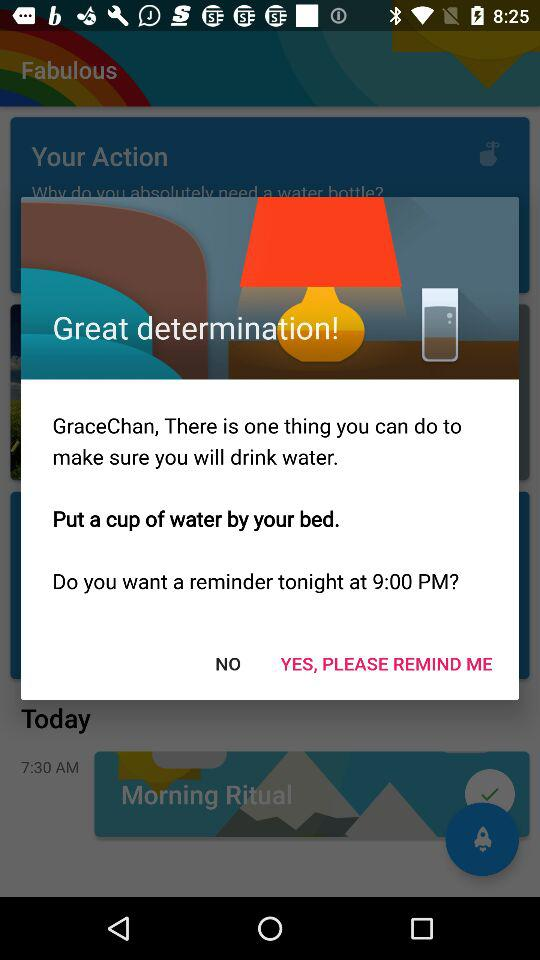What is the username? The username is "GraceChan". 